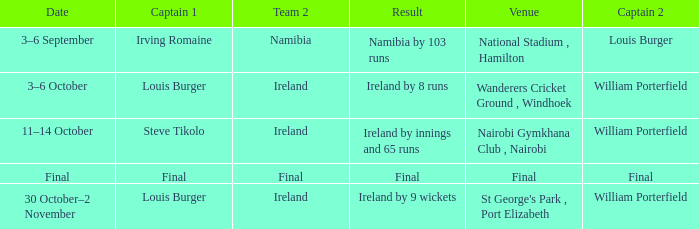Which Captain 2 has a Result of ireland by 8 runs? William Porterfield. 